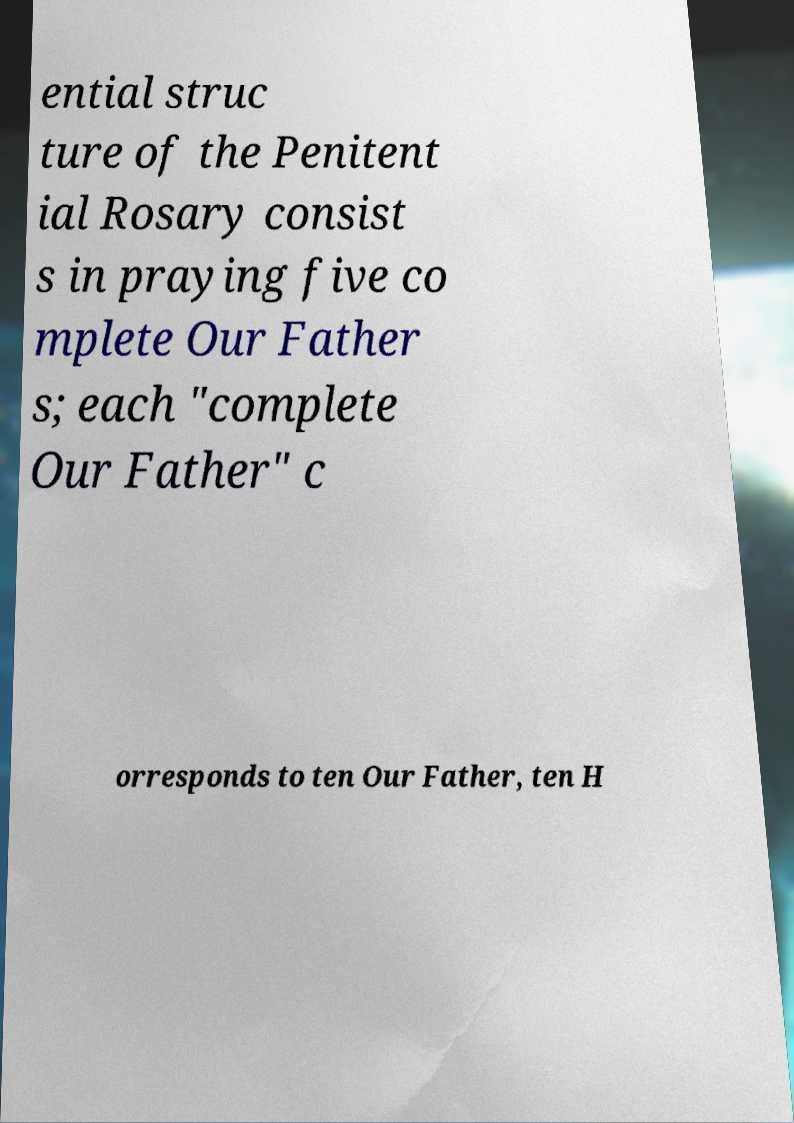There's text embedded in this image that I need extracted. Can you transcribe it verbatim? ential struc ture of the Penitent ial Rosary consist s in praying five co mplete Our Father s; each "complete Our Father" c orresponds to ten Our Father, ten H 